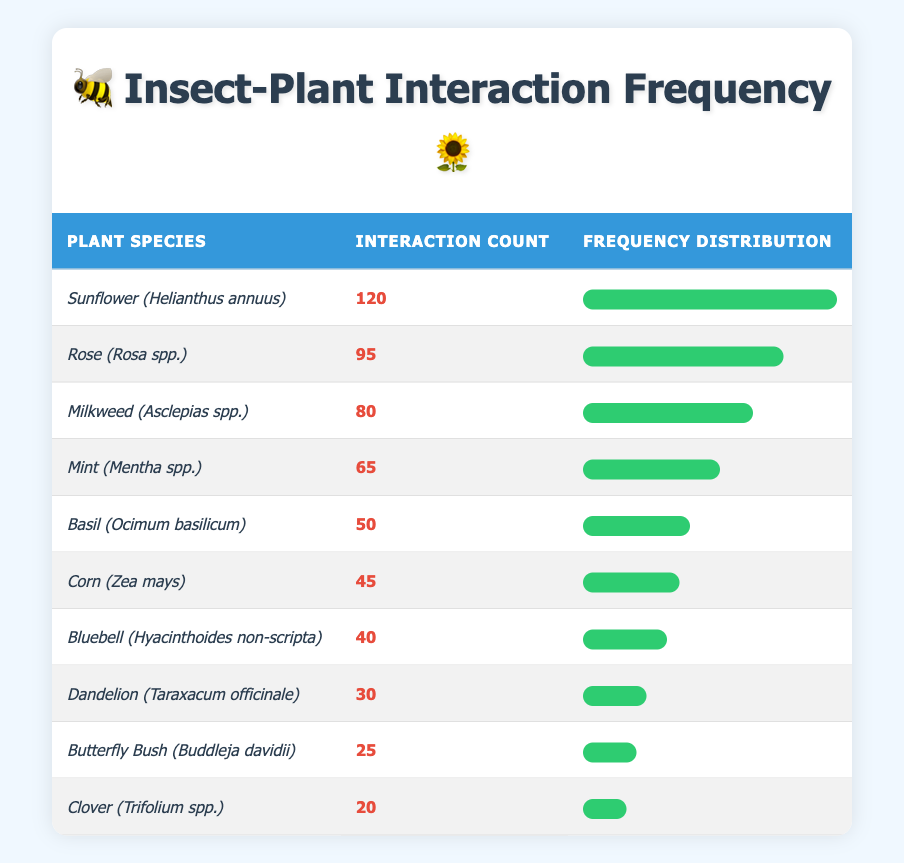What is the highest interaction count recorded in the table? The highest interaction count corresponds to the Sunflower (Helianthus annuus) which has an interaction count of 120. This can be directly identified from the first row of the table.
Answer: 120 How many interaction counts greater than 50 are recorded? The interaction counts greater than 50 in the table are for Sunflower (120), Rose (95), Milkweed (80), and Mint (65). There are a total of 4 such entries when counting the rows.
Answer: 4 Is the interaction count for Mint greater than that for Basil? The interaction count for Mint is 65, which is greater than Basil's count of 50, as seen in the corresponding rows of the table.
Answer: Yes What is the sum of interaction counts for the plants that have interaction counts less than 30? The only plant with an interaction count less than 30 is Clover (20). Therefore, the sum of interaction counts is simply 20. For plants with interaction counts below this threshold, no other entries are counted.
Answer: 20 Which plant species has an interaction count closest to the average of all interaction counts? First, we calculate the total interaction count: 120 + 95 + 80 + 65 + 50 + 45 + 40 + 30 + 25 + 20 = 570. There are 10 entries, so the average is 570/10 = 57. The counts closest to 57 are for Mint (65) and Basil (50). Counting both provides insight into the data range.
Answer: Mint (65) and Basil (50) are closest to the average 